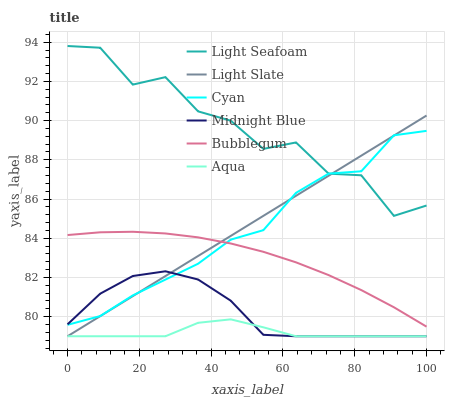Does Aqua have the minimum area under the curve?
Answer yes or no. Yes. Does Light Seafoam have the maximum area under the curve?
Answer yes or no. Yes. Does Light Slate have the minimum area under the curve?
Answer yes or no. No. Does Light Slate have the maximum area under the curve?
Answer yes or no. No. Is Light Slate the smoothest?
Answer yes or no. Yes. Is Light Seafoam the roughest?
Answer yes or no. Yes. Is Aqua the smoothest?
Answer yes or no. No. Is Aqua the roughest?
Answer yes or no. No. Does Bubblegum have the lowest value?
Answer yes or no. No. Does Light Slate have the highest value?
Answer yes or no. No. Is Aqua less than Light Seafoam?
Answer yes or no. Yes. Is Light Seafoam greater than Bubblegum?
Answer yes or no. Yes. Does Aqua intersect Light Seafoam?
Answer yes or no. No. 